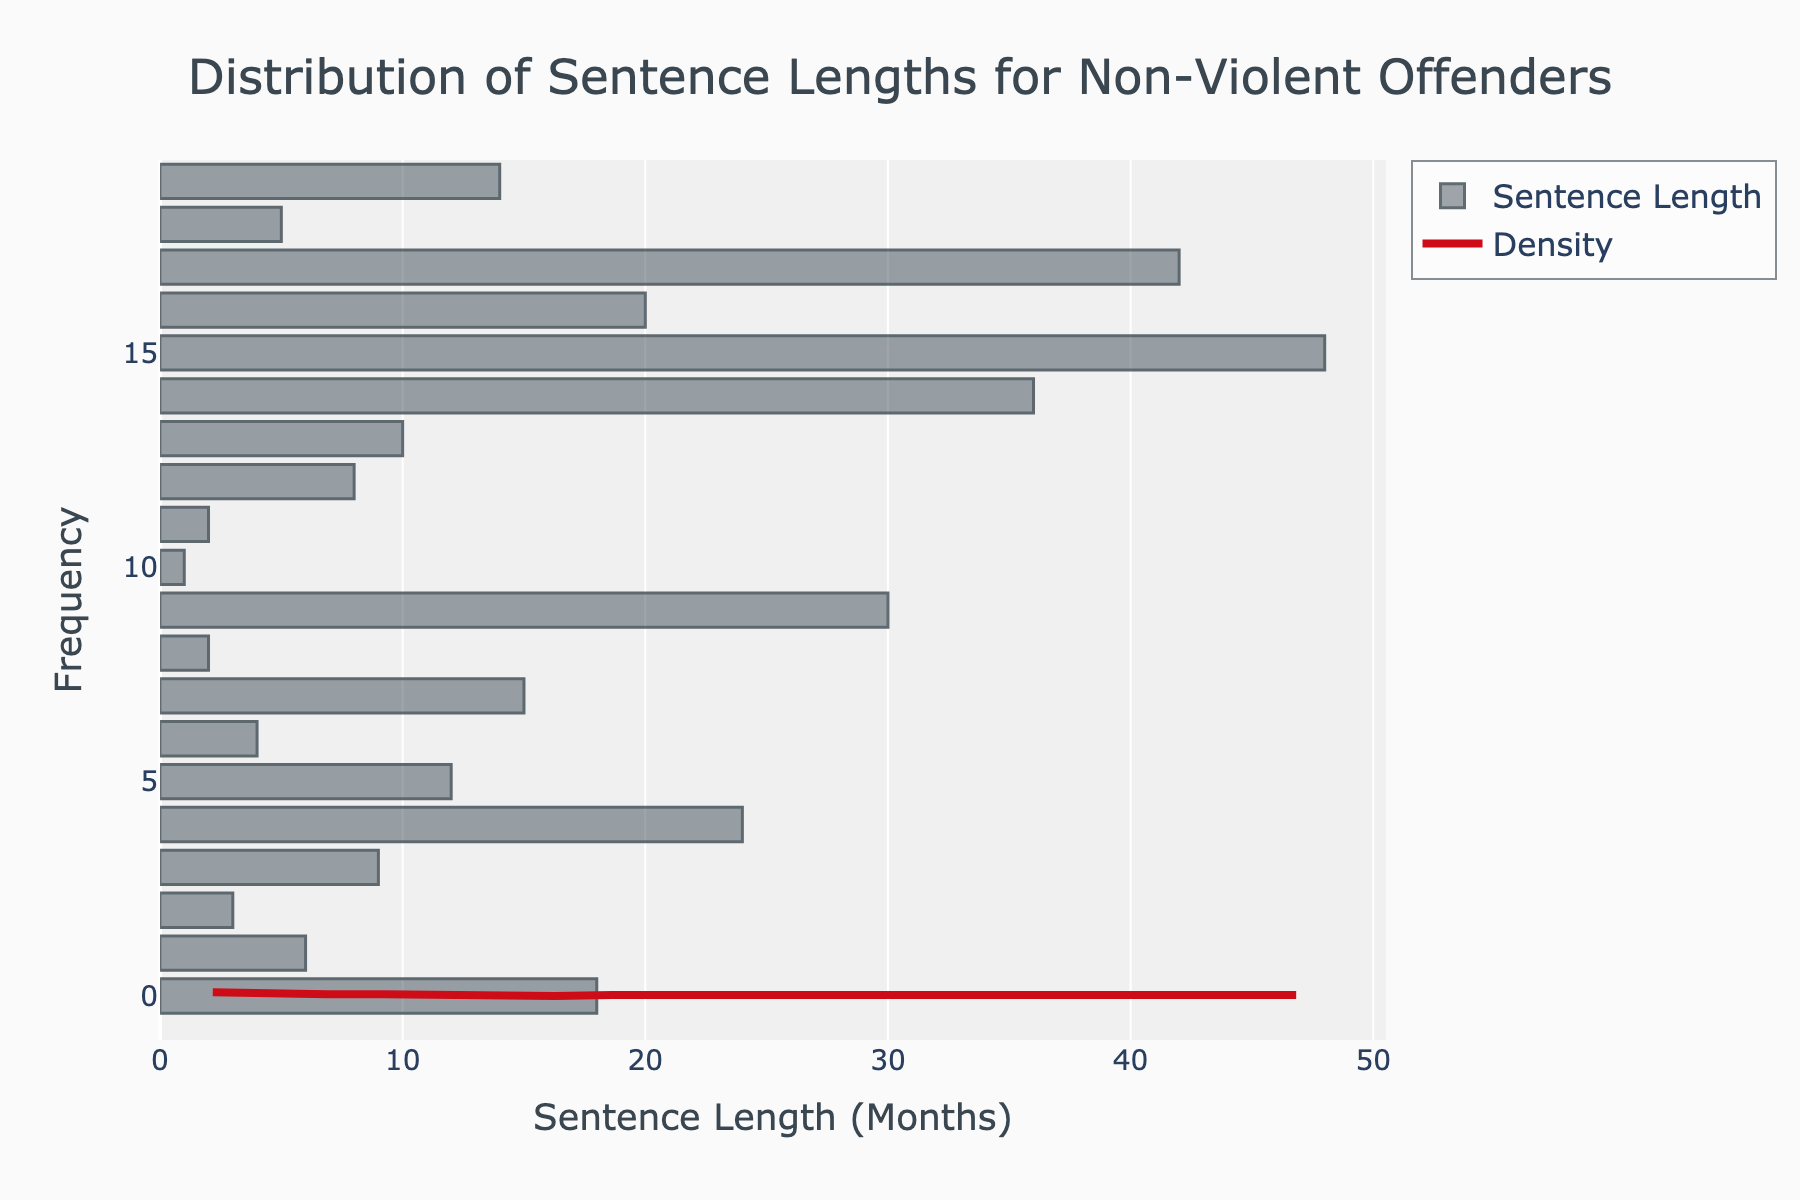What's the title of the figure? Look at the top of the figure where the large text indicates the title.
Answer: Distribution of Sentence Lengths for Non-Violent Offenders What is on the x-axis? The x-axis is labeled.
Answer: Sentence Length (Months) How many months is the longest sentence? Identify the highest value on the x-axis and read the label directly beneath the tallest bar.
Answer: 48 Which sentence length category has the highest density (most frequent)? Look for the highest point in the density curve or the tallest bar in the histogram.
Answer: 2 How many different sentence lengths are shown in the data? Count the number of different bar positions along the x-axis.
Answer: 20 What is the overall trend indicated by the KDE (density) curve? Observe the shape of the density curve to identify whether it increases, decreases, or shows some other pattern.
Answer: Right-skewed What is the frequency of sentences lasting less than 10 months? Sum the frequencies represented by the bars for sentence lengths less than 10 months. The exact heights of the bars and counts are not shown numerically on the histogram but can be inferred from the density and height of nearby bars.
Answer: Less than half the total cases appear to be less than 10 months based on the histogram bar heights Compare sentences of 30 months vs. 10 months. Which is more common? Look at the height of the histogram bars corresponding to 30 months and 10 months.
Answer: 10 months What kind of relationship does the density curve suggest between long sentences and their frequency? Observe the density curve’s trend from lower to higher sentence lengths. It indicates rarity, suggesting fewer long sentences.
Answer: Longer sentences are less frequent Are any sentence length categories notably absent? Compare gaps between the histogram bars and check against all months up to the maximum value on the x-axis.
Answer: Several sentence lengths have no data points, indicating sentences lengths like 7, 11-13, and others are missing in the dataset 